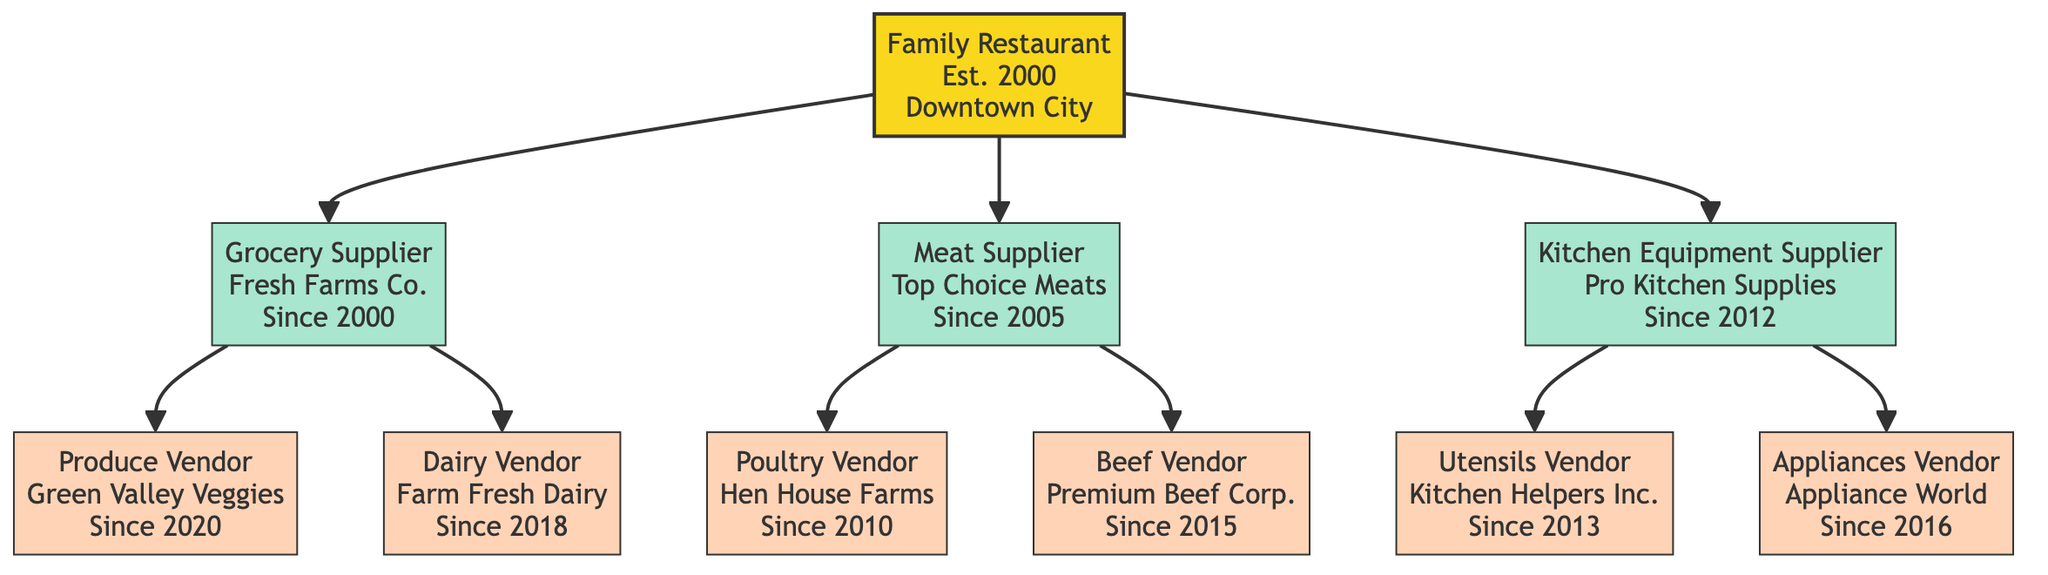What is the main entity in the diagram? The diagram's root node represents the family restaurant, which is the main entity. This is the first node shown in the diagram and is labeled "Family Restaurant."
Answer: Family Restaurant How many suppliers are listed in the diagram? The diagram has three suppliers directly under the main entity node. They can be counted as Grocery Supplier, Meat Supplier, and Kitchen Equipment Supplier.
Answer: 3 Which vendor supplies dairy products? In the diagram, the Dairy Vendor is categorized under the Grocery Supplier branch and is identified as "Farm Fresh Dairy."
Answer: Farm Fresh Dairy What year did the Kitchen Equipment Supplier relationship begin? The relationship with the Kitchen Equipment Supplier, represented by the node "Pro Kitchen Supplies," started in 2012, as indicated next to this node.
Answer: 2012 Who is the contact person for the Produce Vendor? The Produce Vendor node has the contact person labeled as "John Doe," which is listed in the details of that vendor.
Answer: John Doe How many total vendors are under the Meat Supplier? By examining the Meat Supplier branch, it shows two vendor nodes: Poultry Vendor and Beef Vendor. Therefore, the total of vendors under this supplier is two.
Answer: 2 Which vendor started their relationship first among all vendors? The earliest vendor relationship in the diagram is with the Poultry Vendor, which began in 2010. The dates for all vendors are compared, and 2010 is the earliest.
Answer: Poultry Vendor What relationship does "Top Choice Meats" have with the main entity? "Top Choice Meats" is categorized as a Meat Supplier, which is a direct branch from the main entity, indicating a supplier relationship with the Family Restaurant.
Answer: Supplier Which vendor sells appliances? The vendor that provides appliances is labeled as "Appliance World" in the diagram, found under the Kitchen Equipment Supplier branch.
Answer: Appliance World 